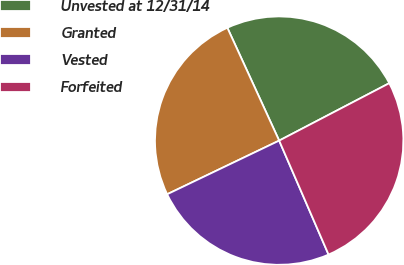<chart> <loc_0><loc_0><loc_500><loc_500><pie_chart><fcel>Unvested at 12/31/14<fcel>Granted<fcel>Vested<fcel>Forfeited<nl><fcel>24.2%<fcel>25.26%<fcel>24.4%<fcel>26.14%<nl></chart> 